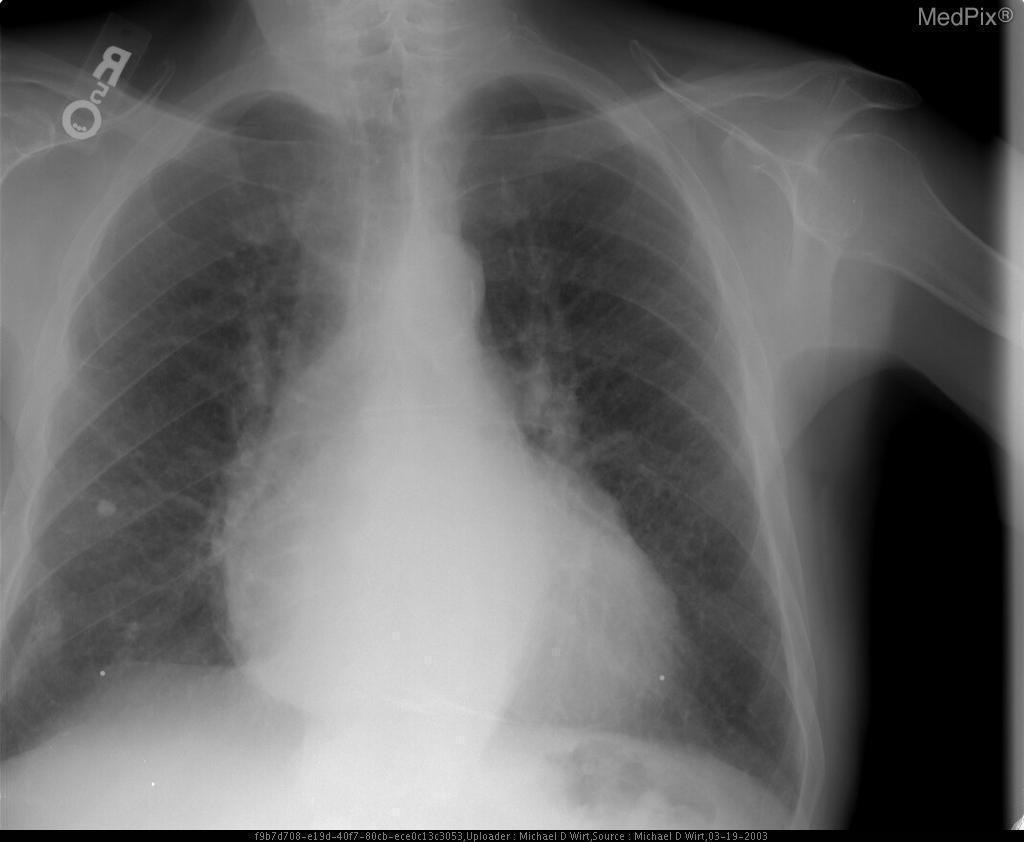Is there cardiomegaly?
Write a very short answer. Yes. Is there deviation in the trachea?
Answer briefly. No. Is there tracheal deviation?
Give a very brief answer. No. Is the heart size abnormal?
Keep it brief. Yes. Are there pleural effusions present?
Short answer required. No. Is there presence of pleural effusions in this patient?
Write a very short answer. No. Is this film taken ap?
Keep it brief. No. Is this a special kind of x-ray?
Be succinct. No. 